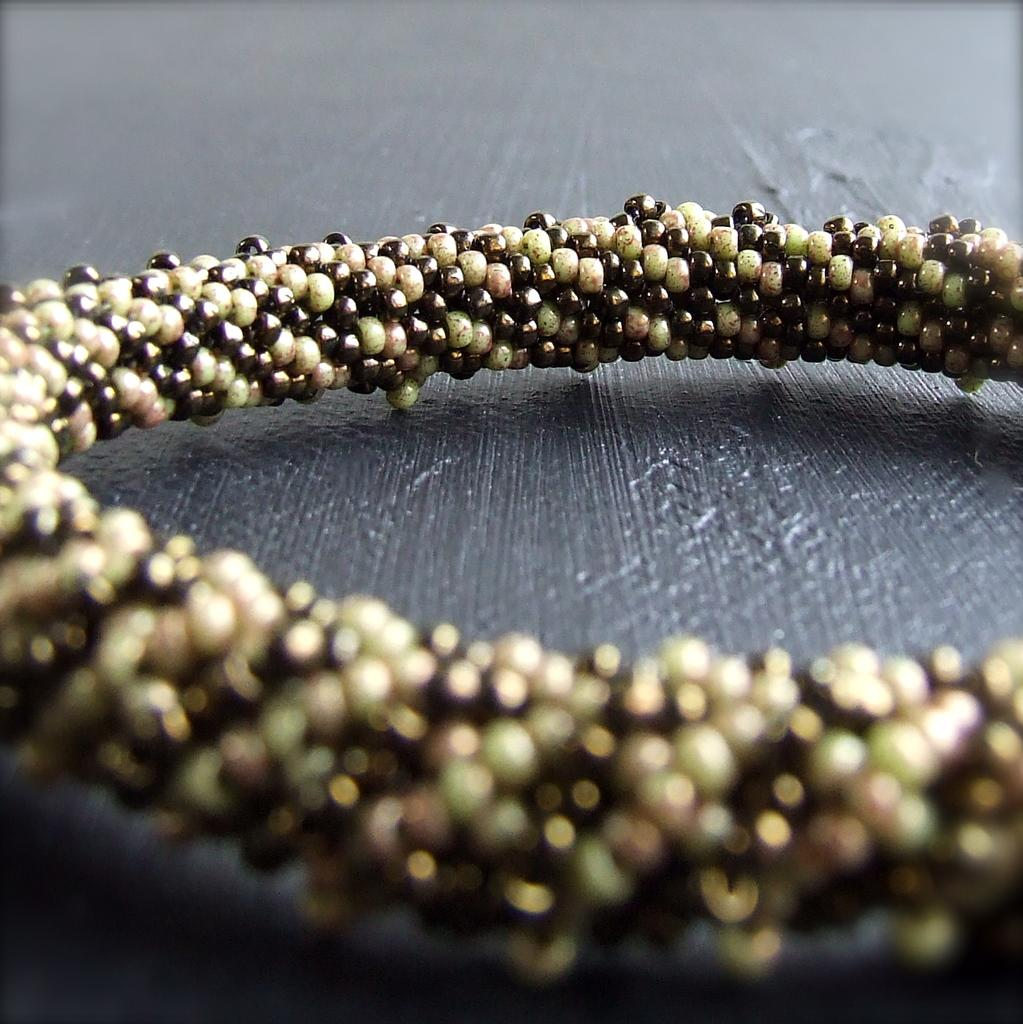What is the main object in the image? There is a bangle in the image. Where is the bangle located? The bangle is placed on a table. What is the color of the table? The table is black in color. What type of music can be heard playing in the background of the image? There is no music or sound present in the image, as it is a still photograph. 